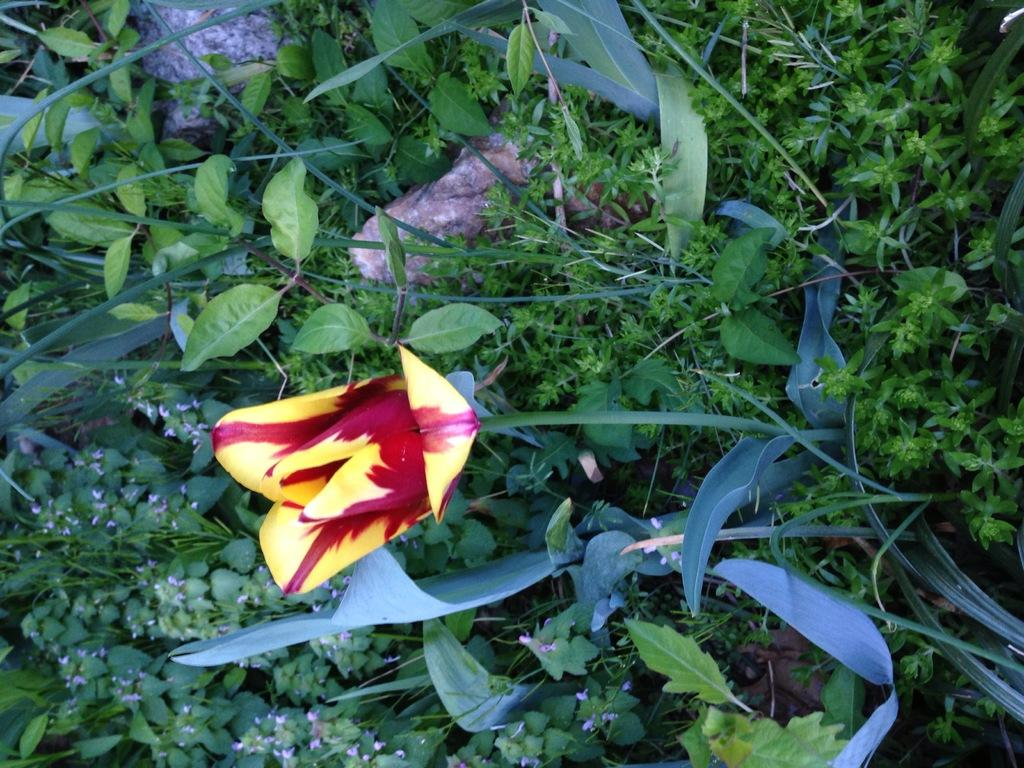What type of vegetation is present in the image? There is grass in the image. What other objects can be seen in the image? There are stones and a plant in the image. Is there any floral element in the image? Yes, there is a flower in the image. What is the condition of the chin in the image? There is no chin present in the image, as it features grass, stones, a plant, and a flower. 